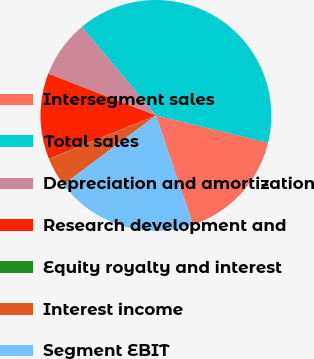<chart> <loc_0><loc_0><loc_500><loc_500><pie_chart><fcel>Intersegment sales<fcel>Total sales<fcel>Depreciation and amortization<fcel>Research development and<fcel>Equity royalty and interest<fcel>Interest income<fcel>Segment EBIT<nl><fcel>15.99%<fcel>39.89%<fcel>8.03%<fcel>12.01%<fcel>0.06%<fcel>4.04%<fcel>19.98%<nl></chart> 